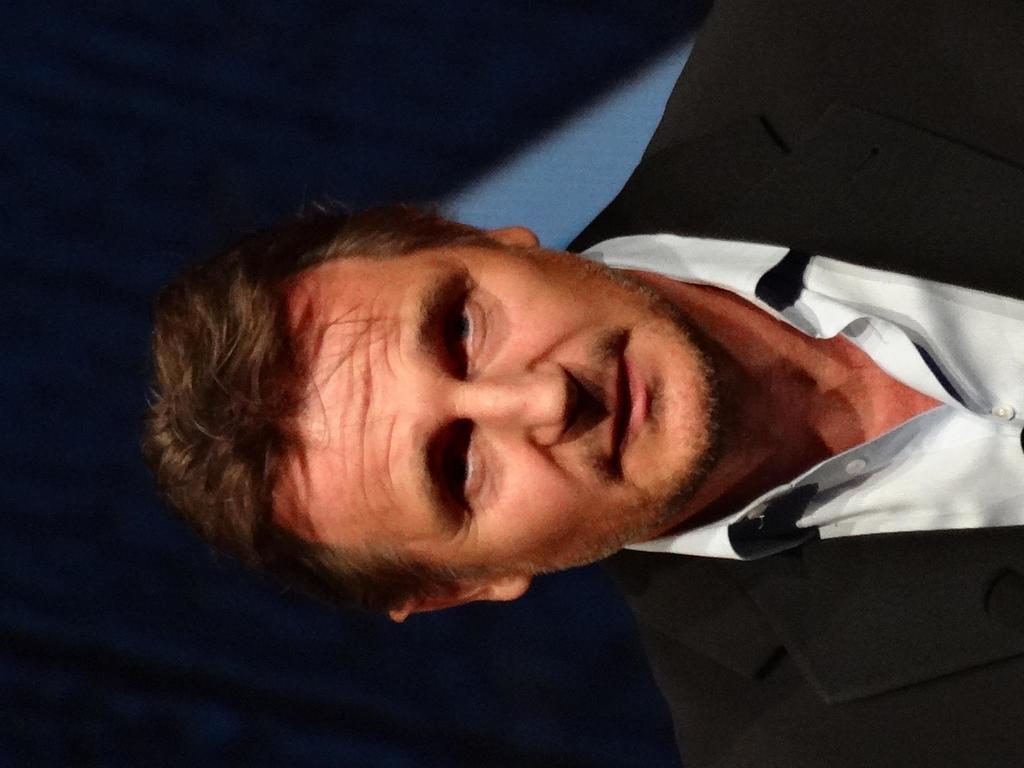Please provide a concise description of this image. In this picture we can see a man wore a blazer and smiling and in the background we can see a curtain. 